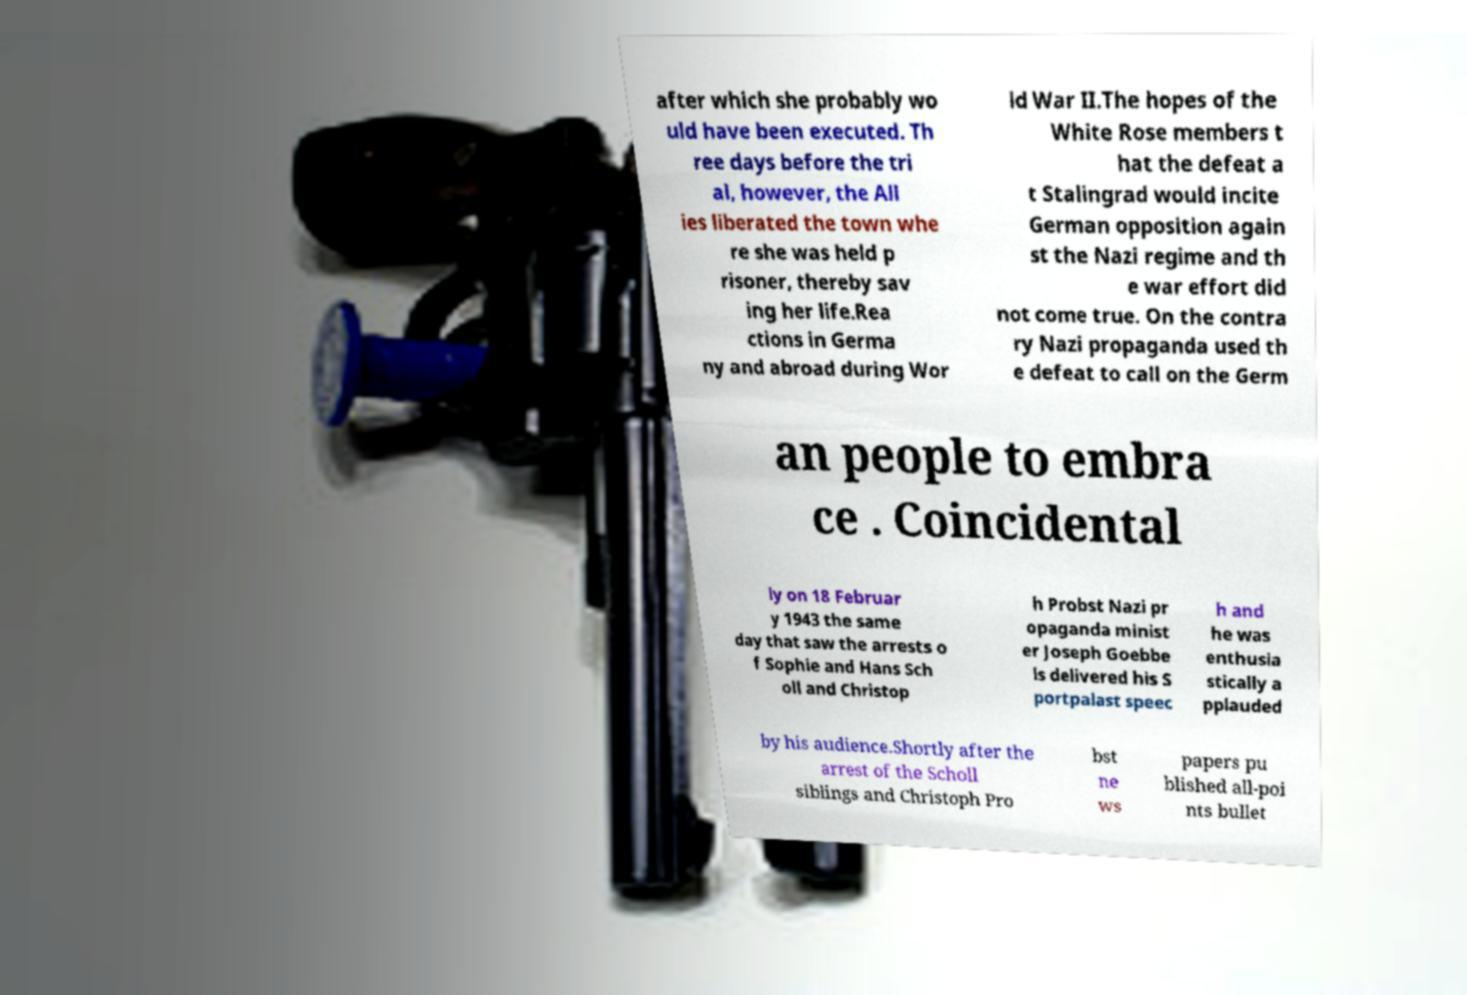Can you accurately transcribe the text from the provided image for me? after which she probably wo uld have been executed. Th ree days before the tri al, however, the All ies liberated the town whe re she was held p risoner, thereby sav ing her life.Rea ctions in Germa ny and abroad during Wor ld War II.The hopes of the White Rose members t hat the defeat a t Stalingrad would incite German opposition again st the Nazi regime and th e war effort did not come true. On the contra ry Nazi propaganda used th e defeat to call on the Germ an people to embra ce . Coincidental ly on 18 Februar y 1943 the same day that saw the arrests o f Sophie and Hans Sch oll and Christop h Probst Nazi pr opaganda minist er Joseph Goebbe ls delivered his S portpalast speec h and he was enthusia stically a pplauded by his audience.Shortly after the arrest of the Scholl siblings and Christoph Pro bst ne ws papers pu blished all-poi nts bullet 